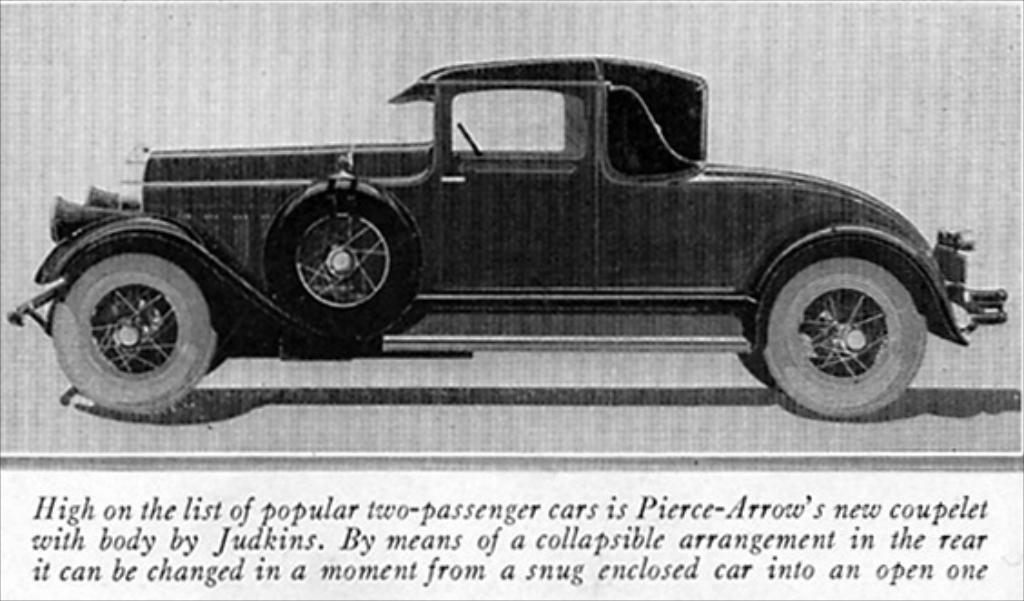What is depicted on the paper in the image? There is a picture of a car printed on a paper. Is there any text accompanying the picture of the car? Yes, there is text printed below the picture of the car. What type of stew is being cooked in the image? There is no stew present in the image; it features a picture of a car printed on a paper with accompanying text. What emotion does the car in the image appear to be experiencing? Cars do not have emotions, so this question cannot be answered based on the image. 